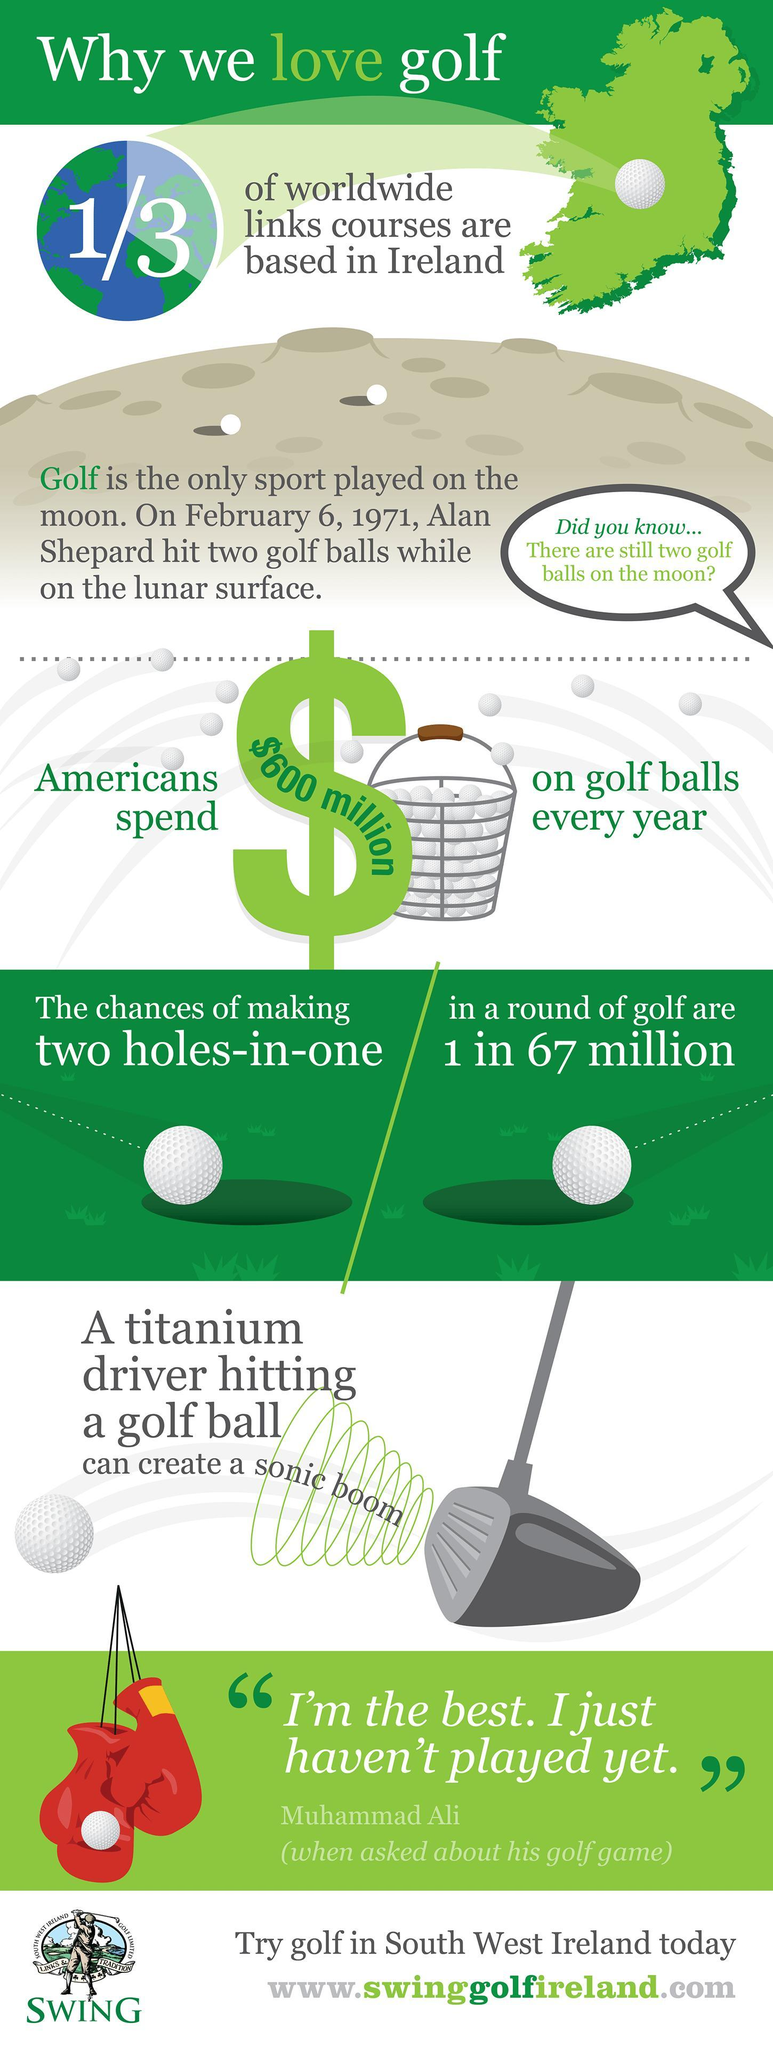Which famous Boxer, when asked about Golf said - "I'm the best. I just haven't played yet"?
Answer the question with a short phrase. Muhammad Ali How many dollars does Americans pend on Golf Balls every year? $600 Million Which is the only sport to be played on the moon? Golf 